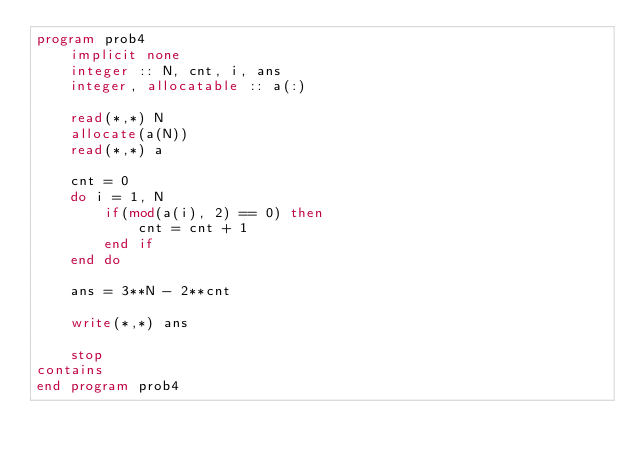<code> <loc_0><loc_0><loc_500><loc_500><_FORTRAN_>program prob4
    implicit none
    integer :: N, cnt, i, ans
    integer, allocatable :: a(:)

    read(*,*) N
    allocate(a(N))
    read(*,*) a
    
    cnt = 0
    do i = 1, N
        if(mod(a(i), 2) == 0) then
            cnt = cnt + 1
        end if
    end do

    ans = 3**N - 2**cnt

    write(*,*) ans

    stop
contains
end program prob4   </code> 